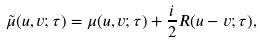<formula> <loc_0><loc_0><loc_500><loc_500>\tilde { \mu } ( u , v ; \tau ) = \mu ( u , v ; \tau ) + \frac { i } { 2 } R ( u - v ; \tau ) ,</formula> 